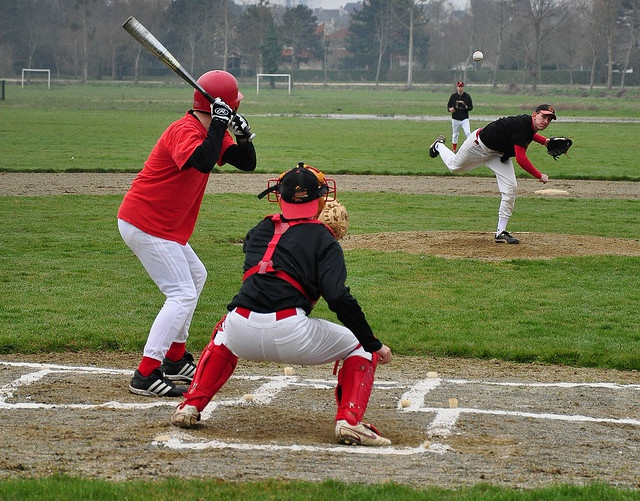Describe the objects in this image and their specific colors. I can see people in purple, black, brown, darkgray, and lightgray tones, people in purple, brown, black, lavender, and darkgray tones, people in purple, black, lightgray, darkgray, and gray tones, baseball bat in purple, gray, black, darkgray, and lightgray tones, and people in purple, black, lavender, darkgray, and gray tones in this image. 